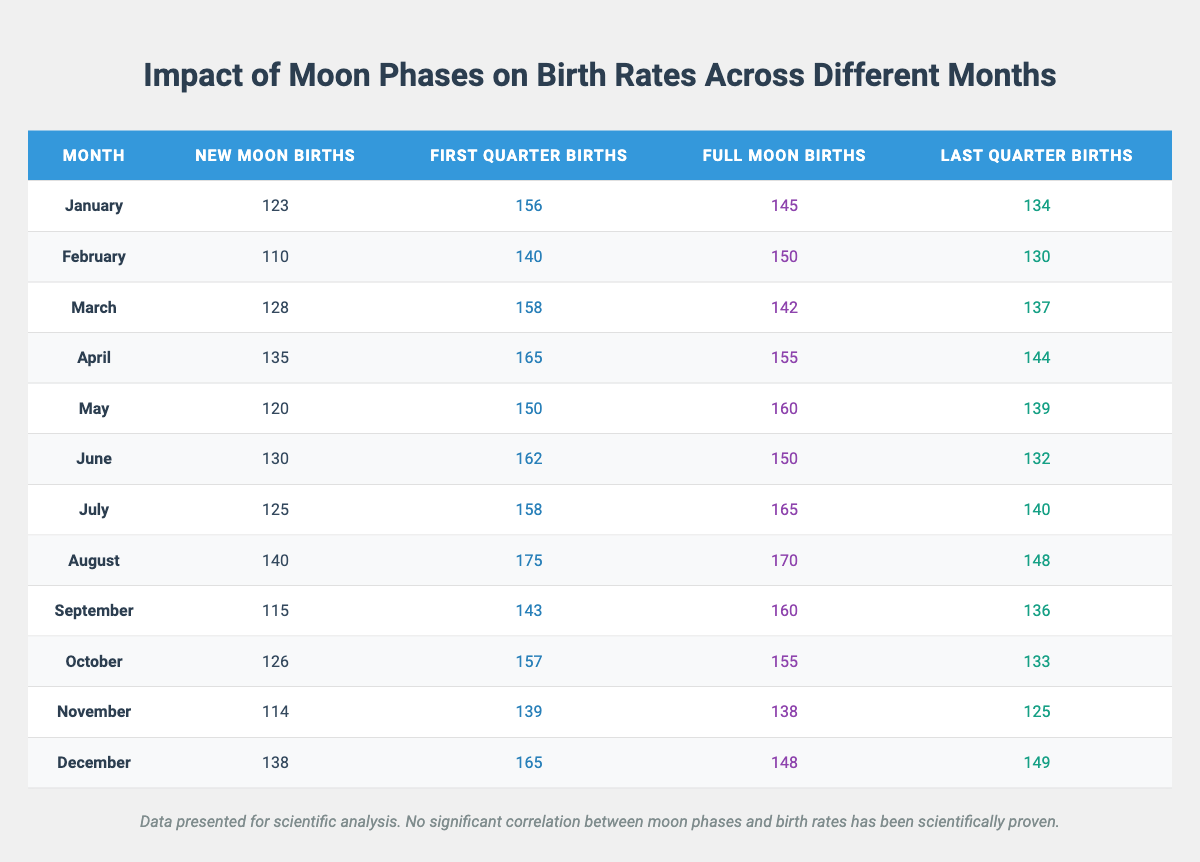What is the number of births during the full moon in December? The table shows the number of full moon births in December as 148.
Answer: 148 Which month has the highest number of births during the new moon? By examining the table, August has the highest new moon births listed as 140.
Answer: August What is the total number of births during the full moon across all months? Summing the full moon births: 145 + 150 + 142 + 155 + 160 + 150 + 165 + 170 + 160 + 155 + 138 + 148 = 1835.
Answer: 1835 How many more births occur during the first quarter in April compared to February? The first quarter births for April is 165 and for February, it's 140; calculating the difference: 165 - 140 = 25.
Answer: 25 Which moon phase had the lowest total number of births in the table? Observing the table, new moon births across all months total to 1493, which is lower than other phases.
Answer: New Moon What is the average number of births during the last quarter across all months? Calculating the total births during the last quarter: 134 + 130 + 137 + 144 + 139 + 132 + 140 + 148 + 136 + 133 + 125 + 149 = 1617; dividing by the number of months (12): 1617 / 12 = 134.75.
Answer: 134.75 Does the full moon phase consistently have the highest number of births across all months? No, examining the data, full moon births are not the highest in every month; for example, in August, first quarter has the highest at 175.
Answer: No Which month has the lowest total births across all moon phases? By calculating the total births for each month, November has the lowest total with 114 + 139 + 138 + 125 = 516.
Answer: November What is the difference in total births between new moon and full moon phases for January? In January, new moon births are 123 and full moon births are 145; the difference is 145 - 123 = 22.
Answer: 22 How many months have new moon births fewer than 120? Checking the new moon births, there are three months: February (110), May (120).
Answer: 1 